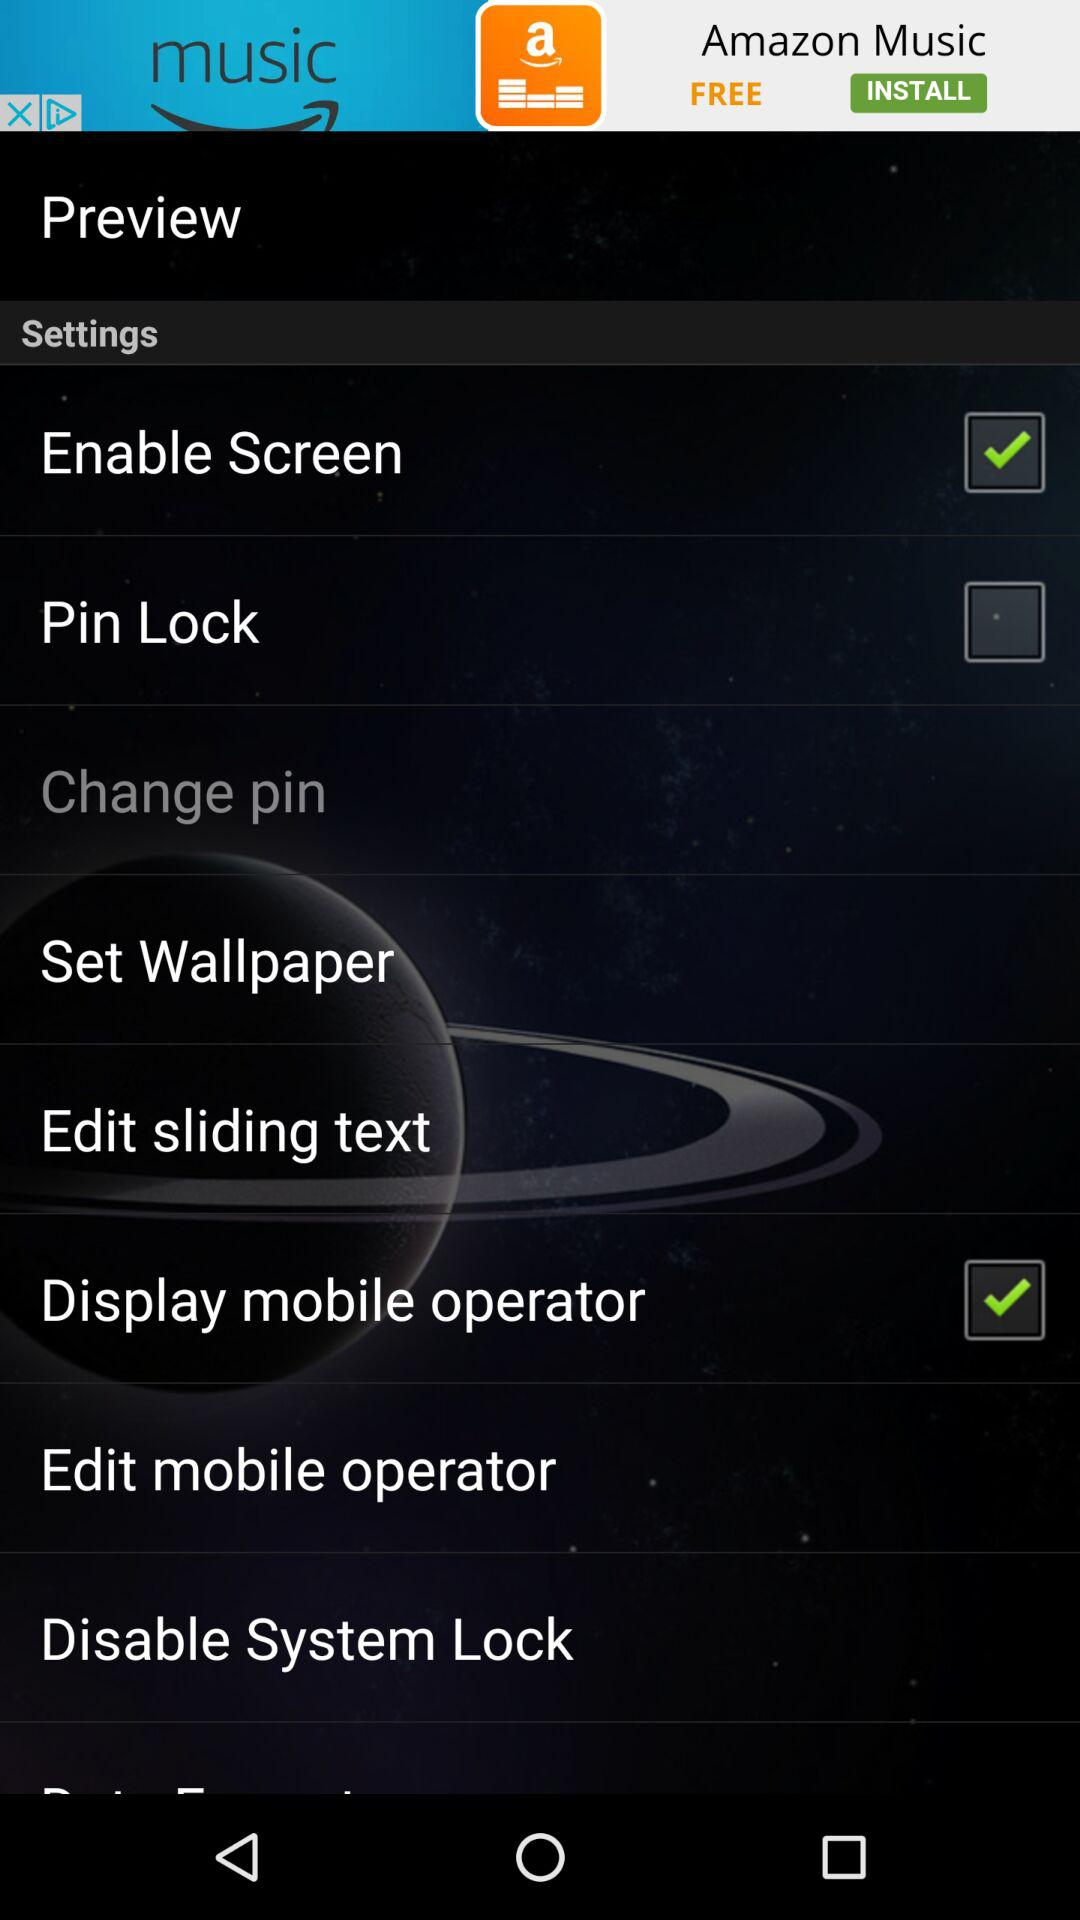What is the status of the pin lock? The status is off. 